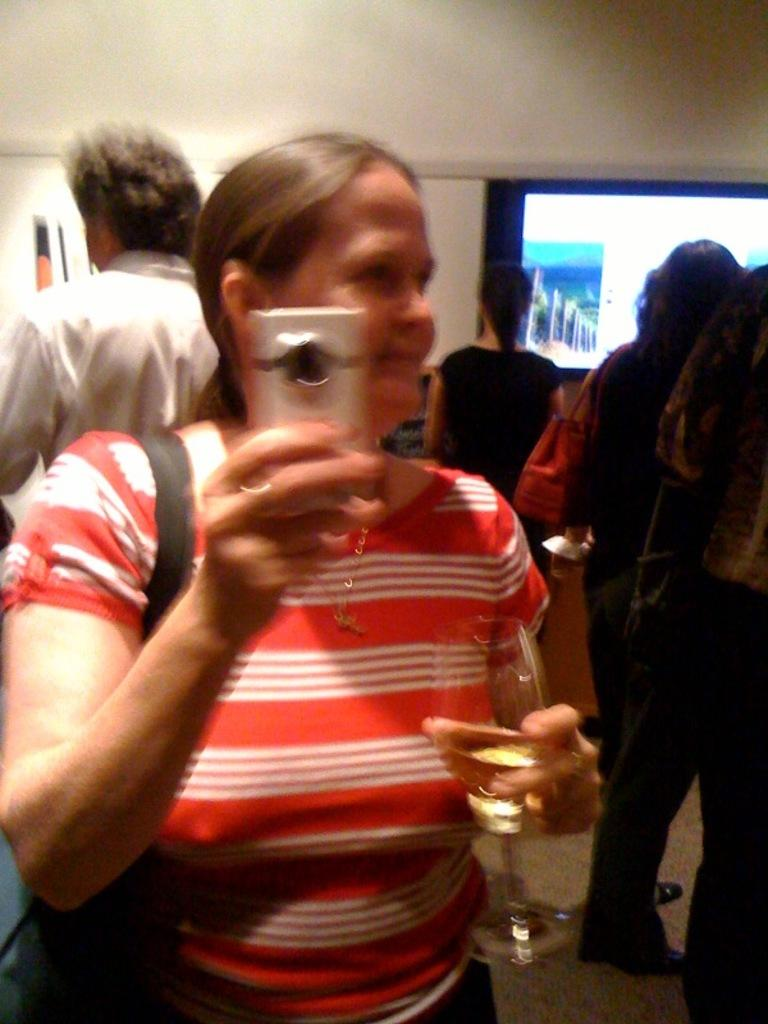What is the main subject of the image? There is a woman in the image. What is the woman wearing? The woman is wearing a bag. What is the woman holding in her hand? The woman is holding an object. What is the woman holding in her other hand? The woman is holding a glass with liquid. What can be seen in the background of the image? There are people, a wall, a screen, a board, a floor, and other objects in the background of the image. Can you describe the motion of the ocean in the image? There is no ocean present in the image, so it is not possible to describe its motion. 